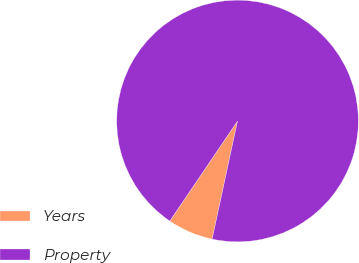Convert chart to OTSL. <chart><loc_0><loc_0><loc_500><loc_500><pie_chart><fcel>Years<fcel>Property<nl><fcel>6.1%<fcel>93.9%<nl></chart> 